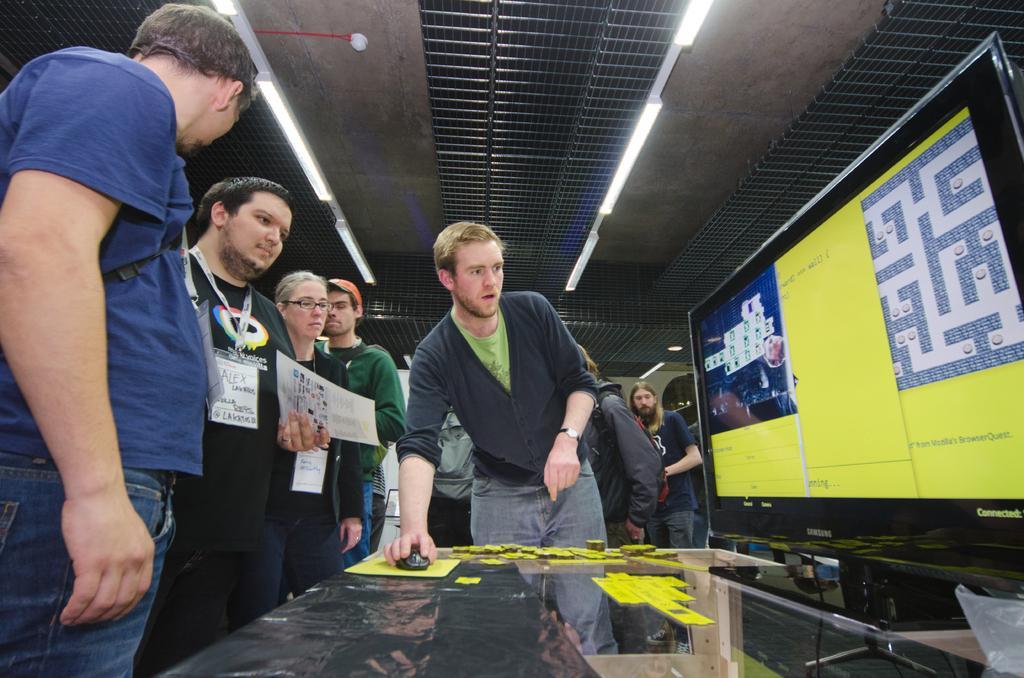Can you describe this image briefly? In this image there are a few people standing, one of them is holding a paper in his hand and the other person has placed his hand on the mouse, which is on the table and there is a monitor. At the top of the image there is a ceiling with lights. 